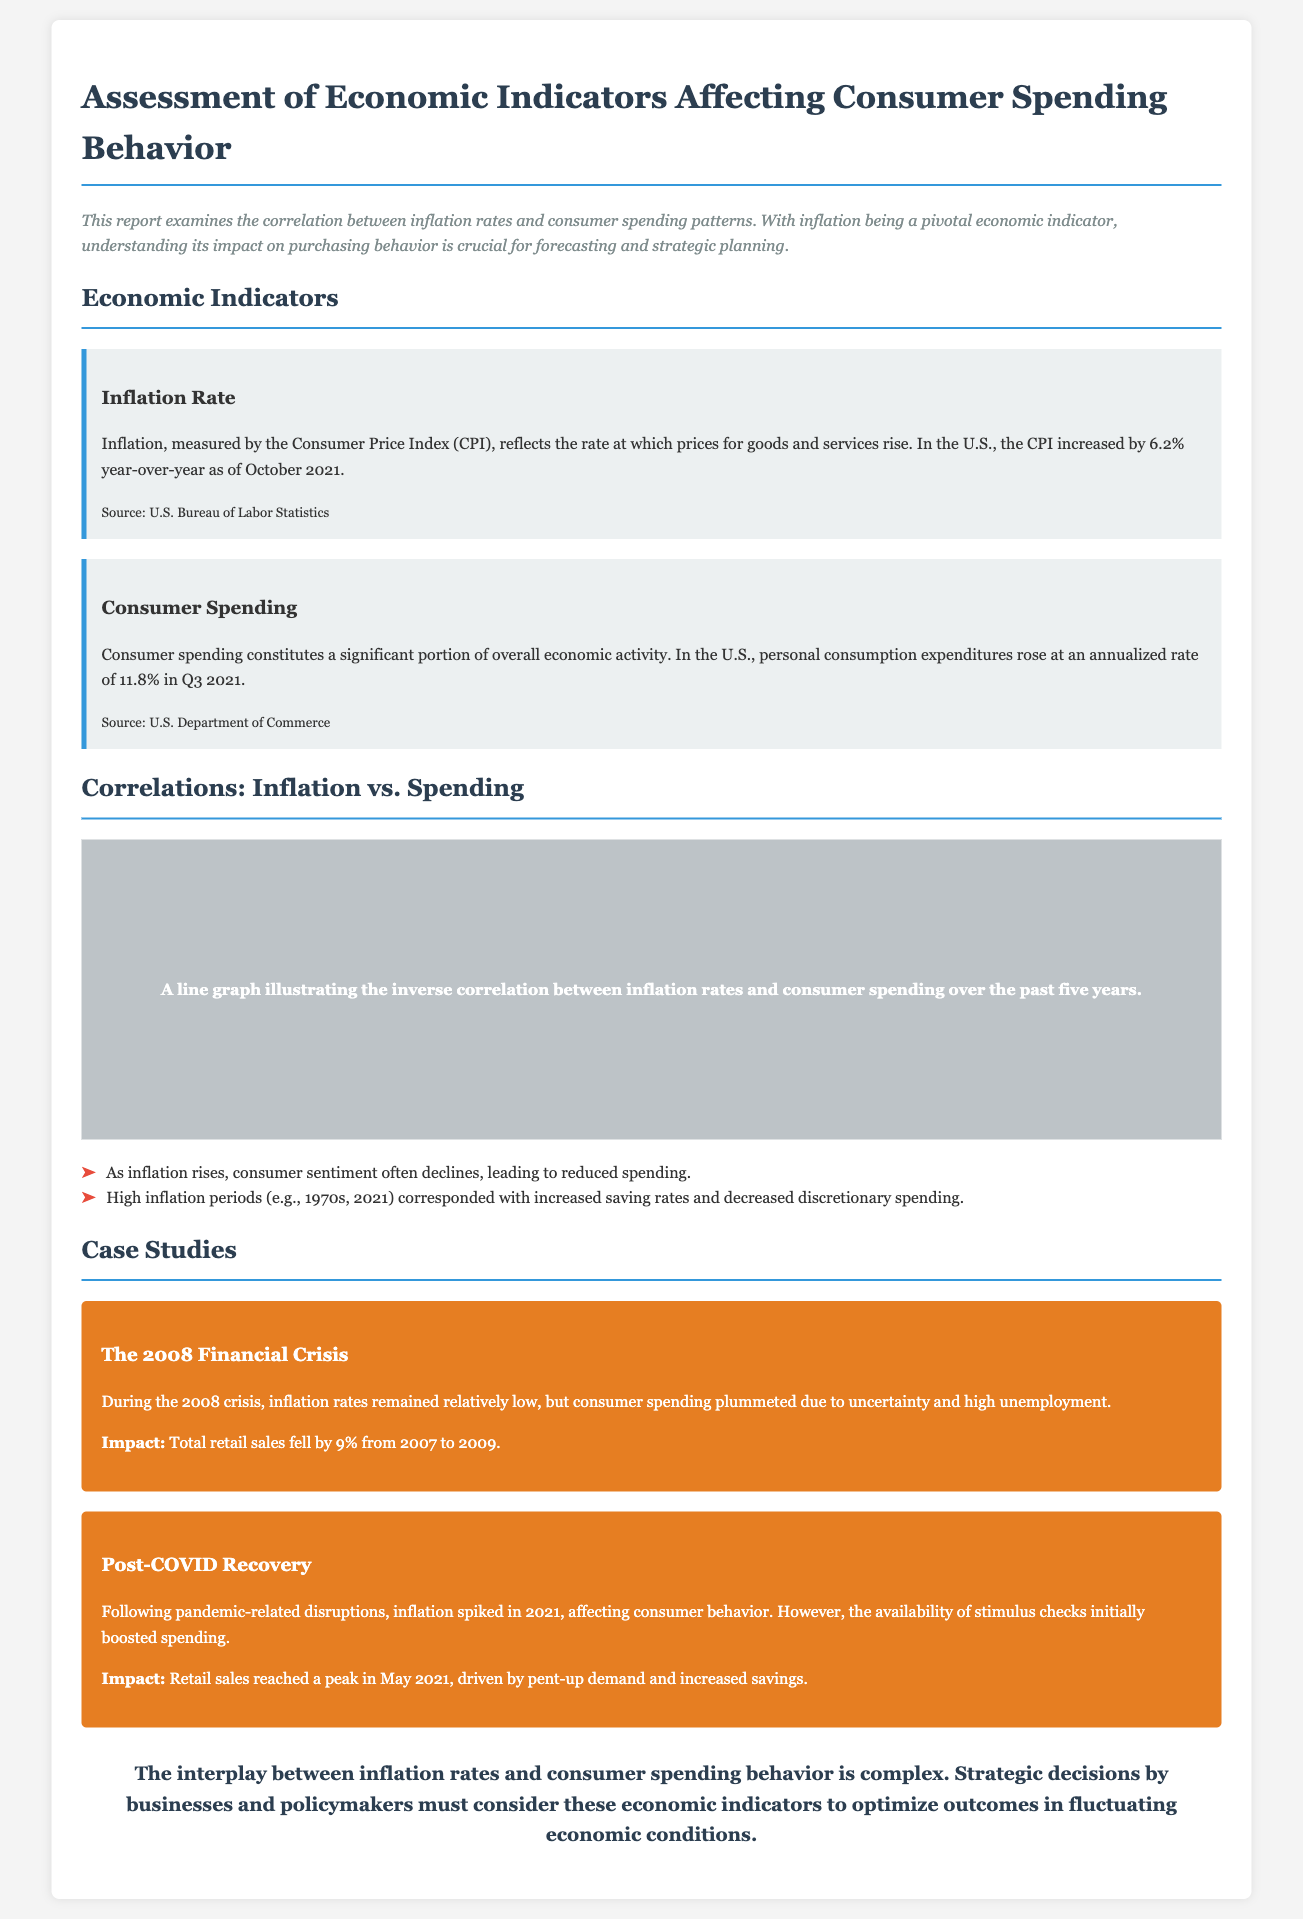What is the inflation rate as of October 2021? The document states that the CPI increased by 6.2% year-over-year as of October 2021.
Answer: 6.2% What was the annualized rate of personal consumption expenditures in Q3 2021? The report indicates that consumer spending rose at an annualized rate of 11.8% in Q3 2021.
Answer: 11.8% What economic period is associated with increased saving rates and decreased discretionary spending? The findings mention that high inflation periods such as the 1970s and 2021 had this characteristic.
Answer: 1970s, 2021 What was the impact on total retail sales from 2007 to 2009? During the 2008 financial crisis, total retail sales fell by 9% according to the case study.
Answer: 9% What drove retail sales to peak in May 2021? The document notes that retail sales were driven by pent-up demand and increased savings following pandemic disruptions.
Answer: Stimulus checks What is the main theme of the report? The introduction highlights the correlation between inflation rates and consumer spending patterns as the primary focus.
Answer: Correlation How does the report classify the economic indicators discussed? The economic indicators are categorized under "Inflation Rate" and "Consumer Spending."
Answer: Two categories What do the findings conclude about consumer sentiment? The findings indicate that as inflation rises, consumer sentiment often declines.
Answer: Declines 